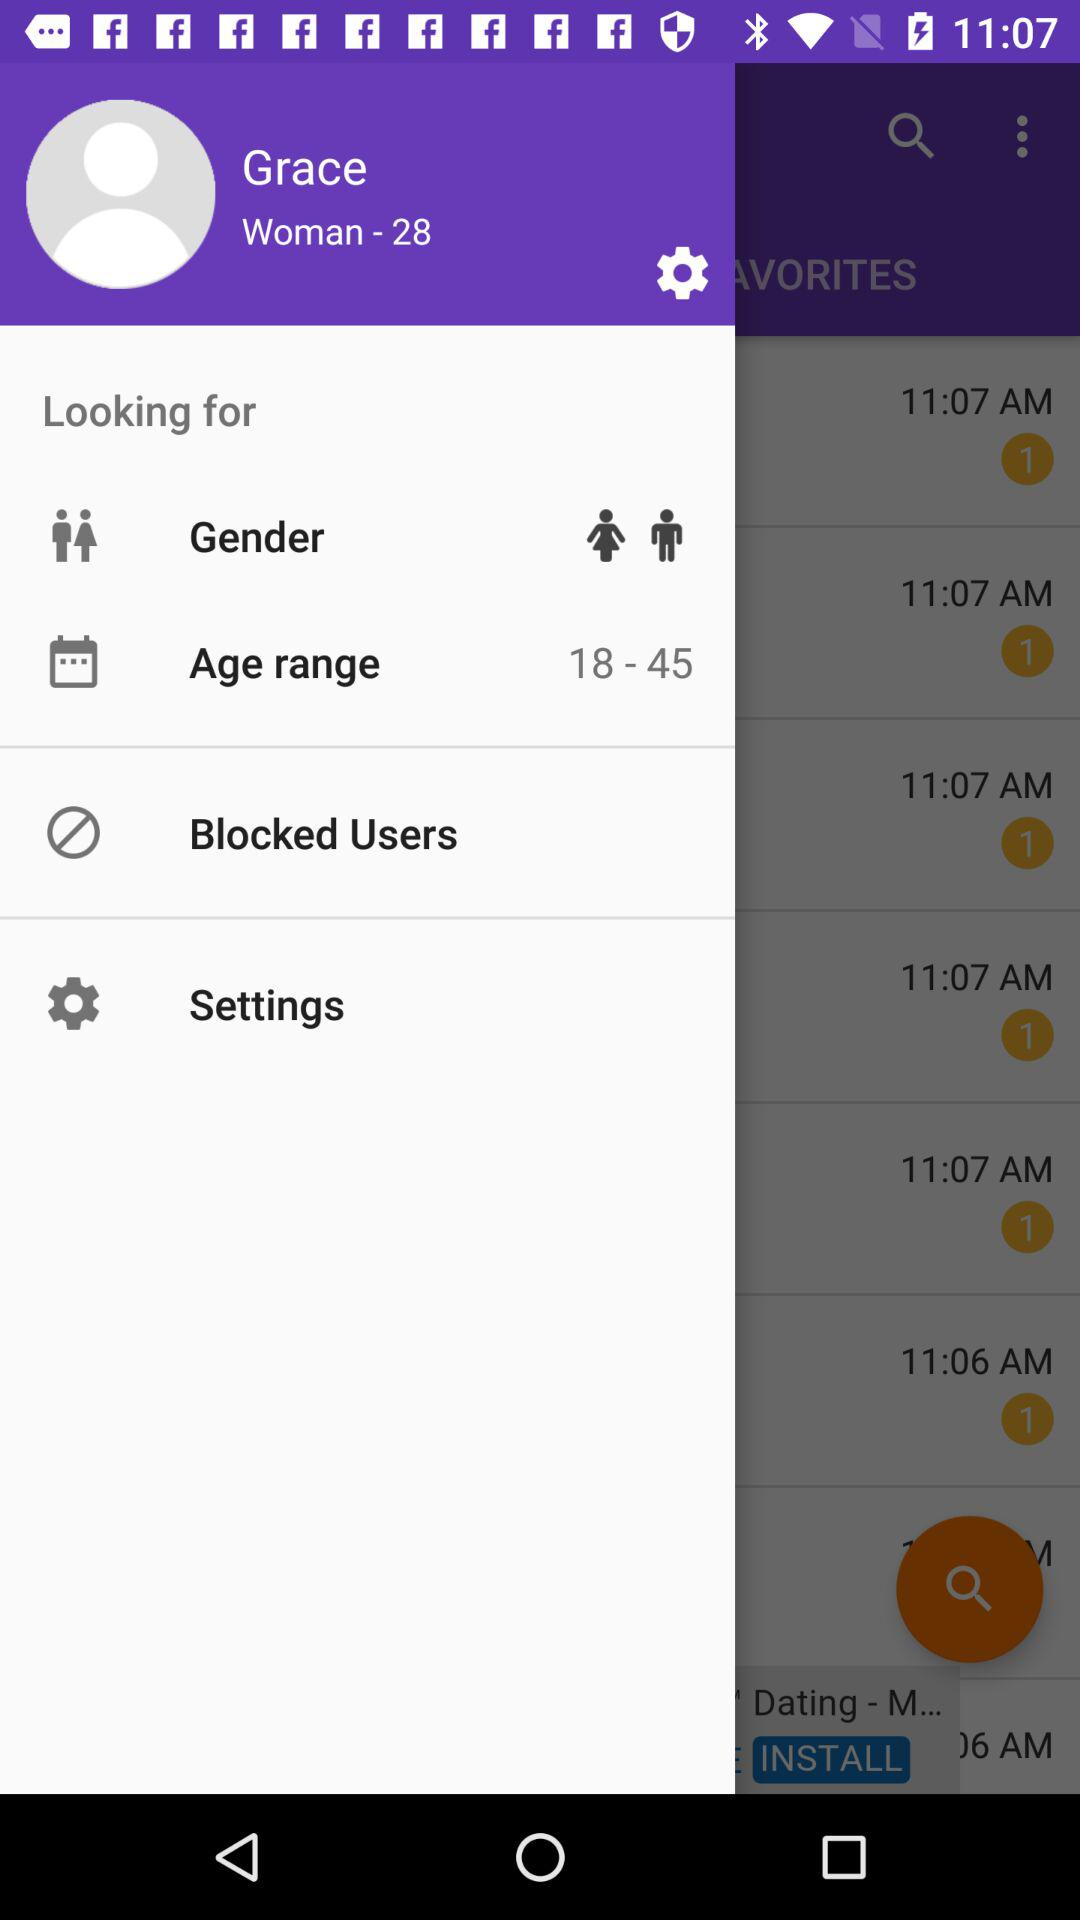What is the user name? The user name is Grace. 